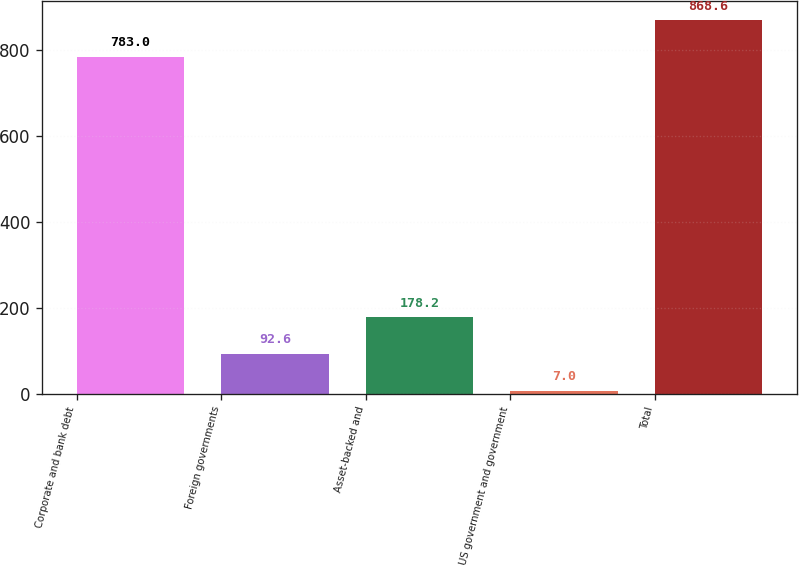Convert chart. <chart><loc_0><loc_0><loc_500><loc_500><bar_chart><fcel>Corporate and bank debt<fcel>Foreign governments<fcel>Asset-backed and<fcel>US government and government<fcel>Total<nl><fcel>783<fcel>92.6<fcel>178.2<fcel>7<fcel>868.6<nl></chart> 